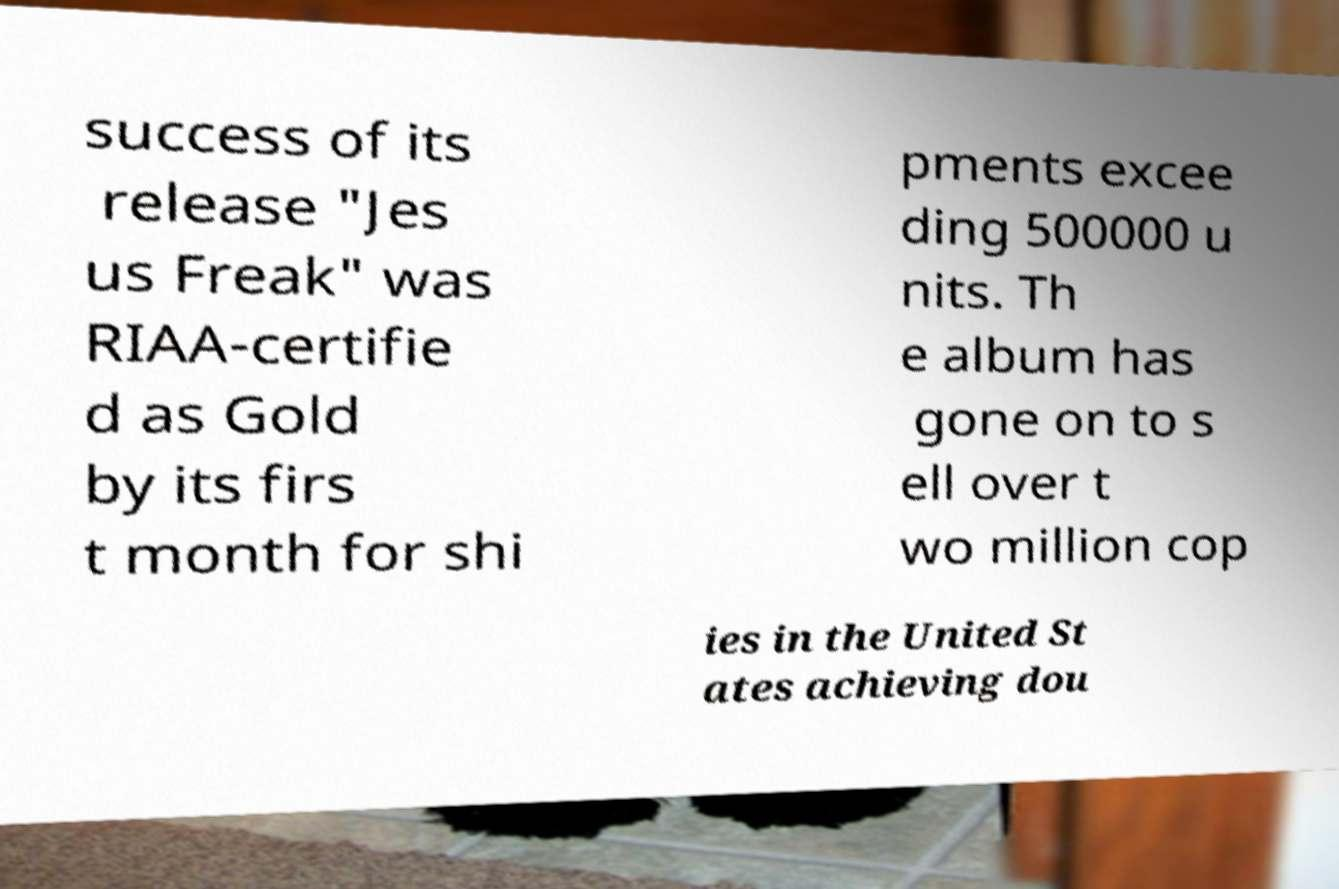Can you accurately transcribe the text from the provided image for me? success of its release "Jes us Freak" was RIAA-certifie d as Gold by its firs t month for shi pments excee ding 500000 u nits. Th e album has gone on to s ell over t wo million cop ies in the United St ates achieving dou 